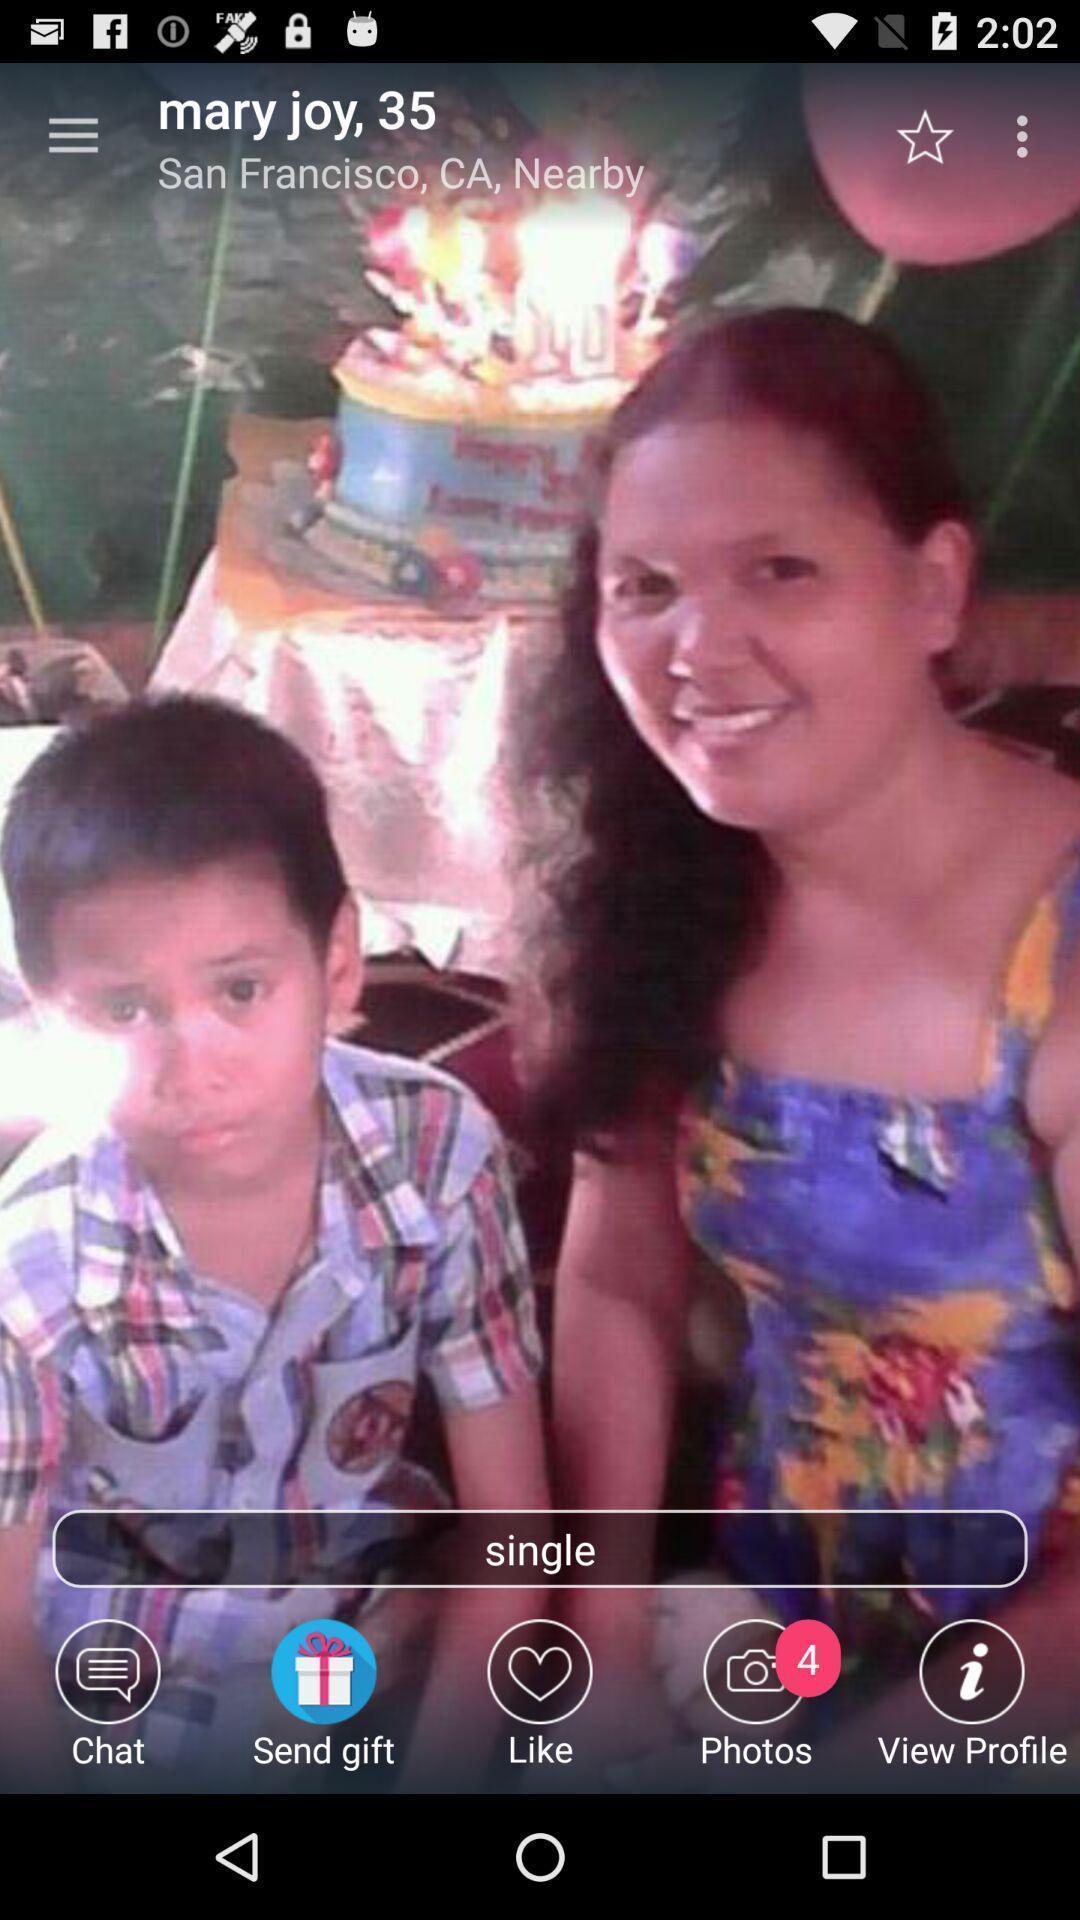Provide a detailed account of this screenshot. Screen shows profile page of person in dating application. 